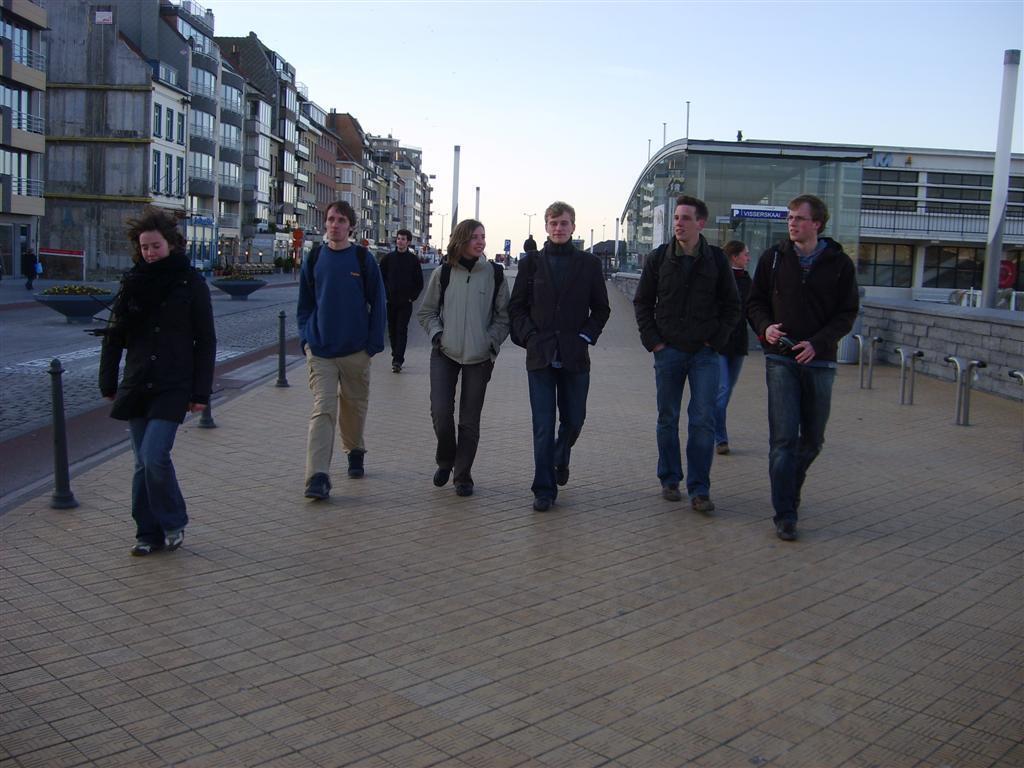In one or two sentences, can you explain what this image depicts? In the picture I can see some persons walking through the footpath, there are some buildings on left and background of the picture and top of the picture there is clear sky. 